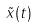<formula> <loc_0><loc_0><loc_500><loc_500>\tilde { x } ( t )</formula> 